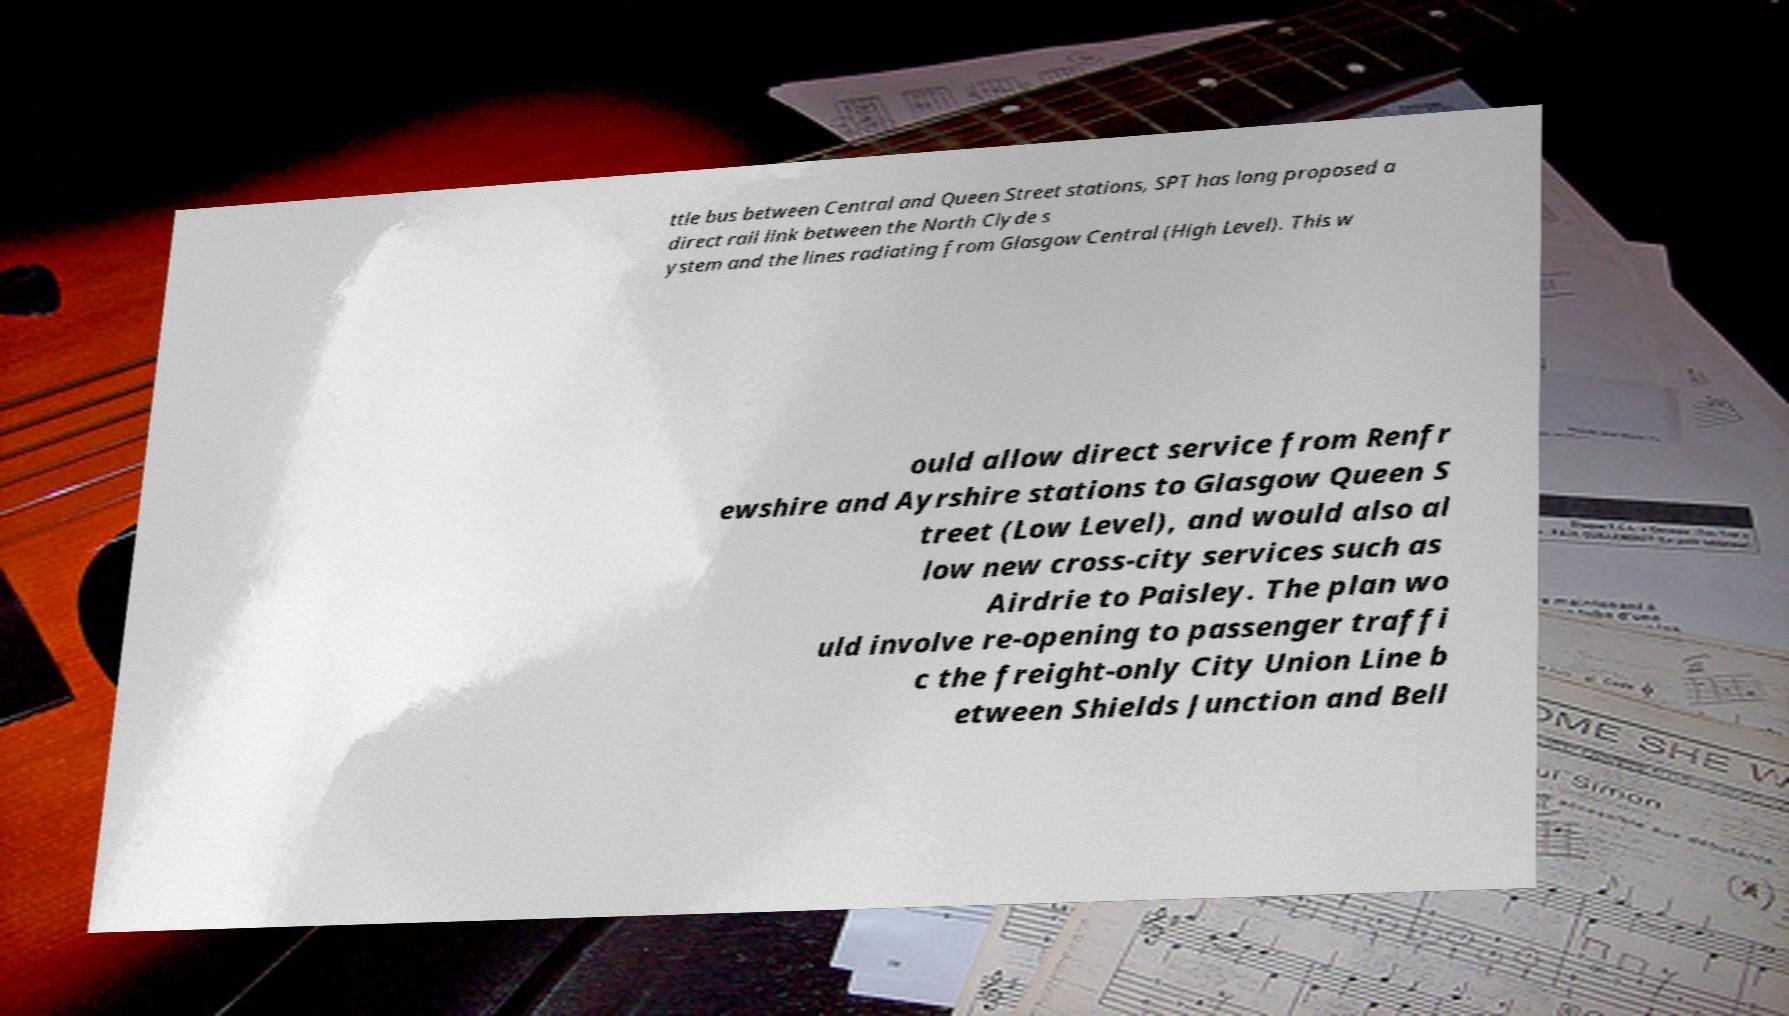Can you accurately transcribe the text from the provided image for me? ttle bus between Central and Queen Street stations, SPT has long proposed a direct rail link between the North Clyde s ystem and the lines radiating from Glasgow Central (High Level). This w ould allow direct service from Renfr ewshire and Ayrshire stations to Glasgow Queen S treet (Low Level), and would also al low new cross-city services such as Airdrie to Paisley. The plan wo uld involve re-opening to passenger traffi c the freight-only City Union Line b etween Shields Junction and Bell 